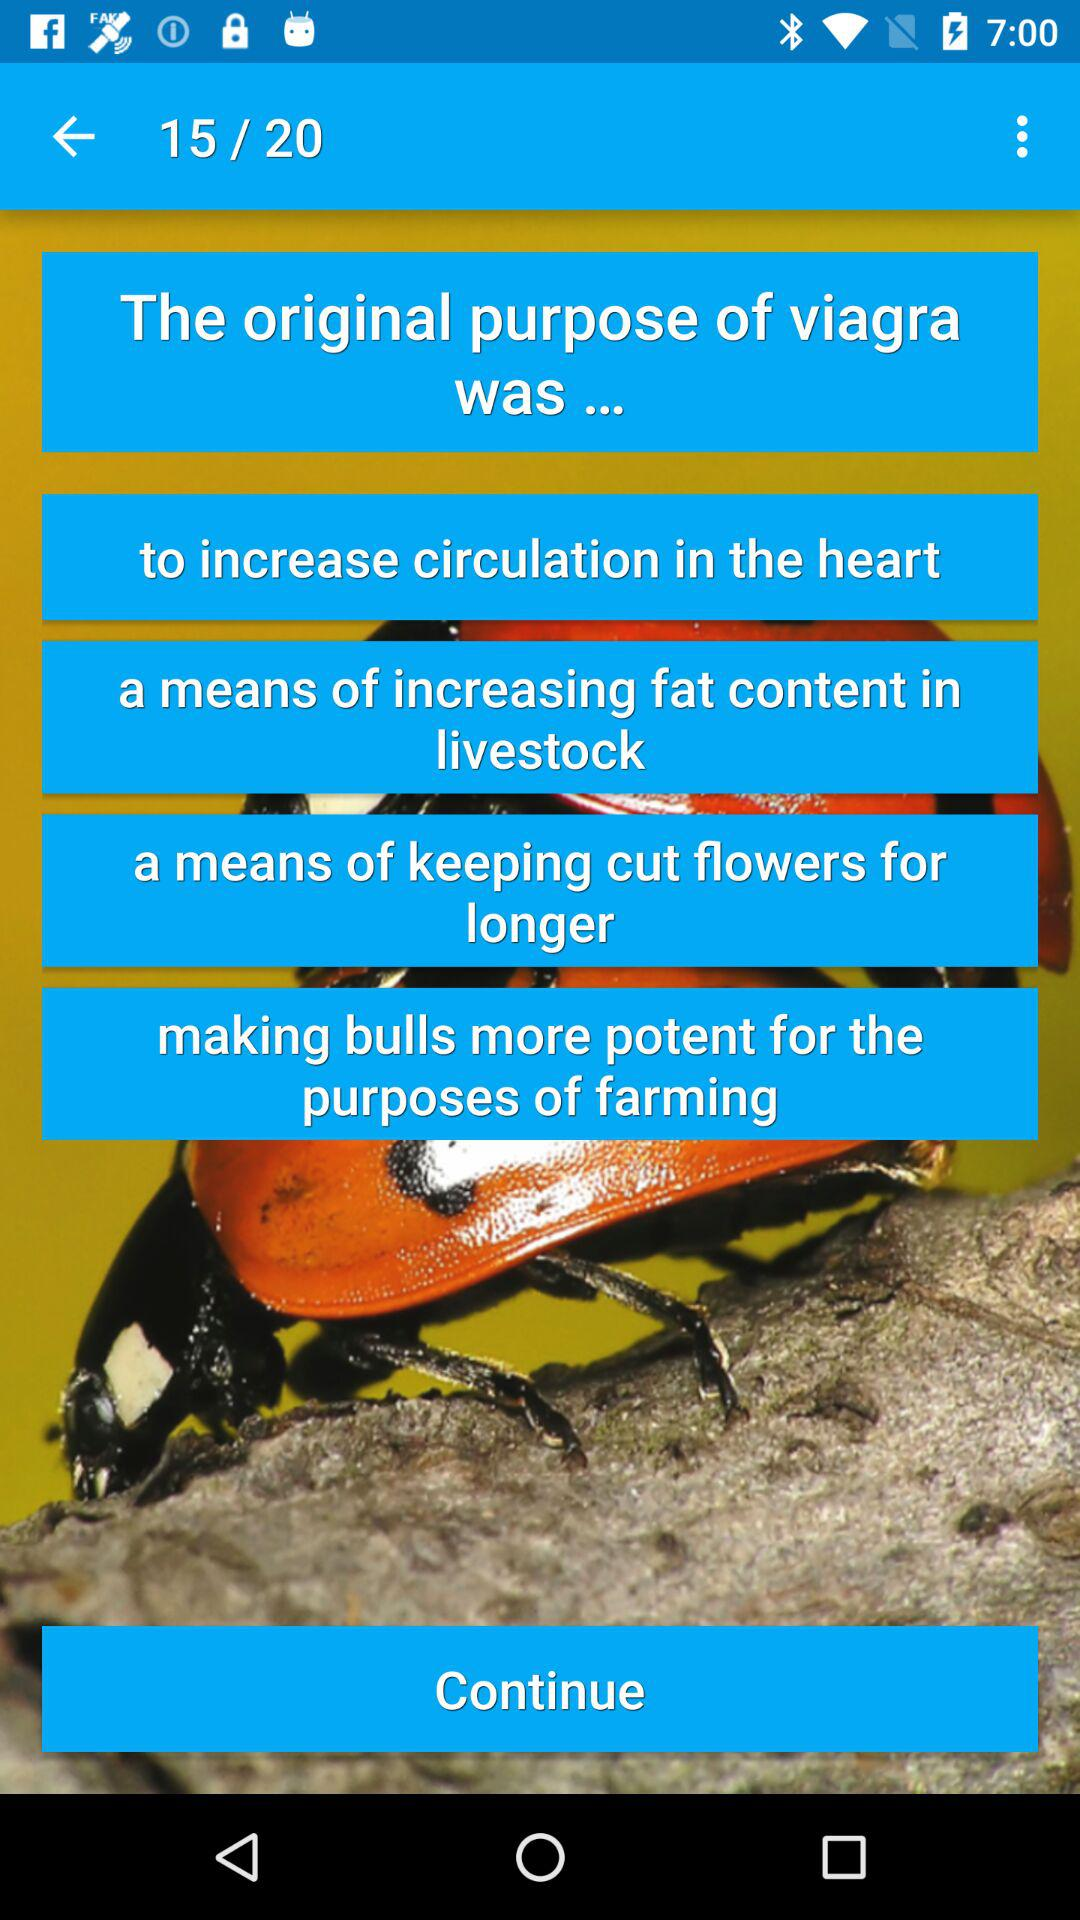Which page are we currently on? You are currently on the fifteenth page. 